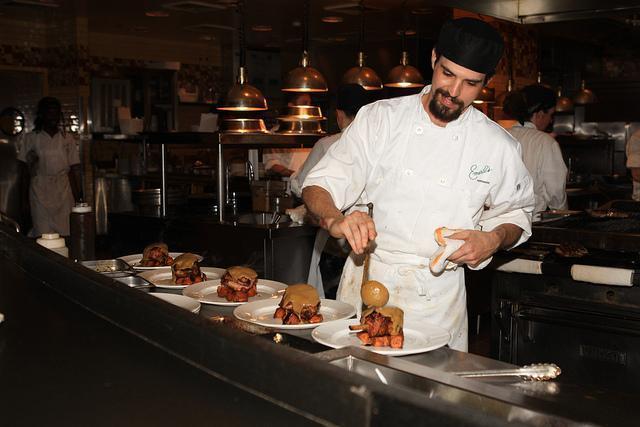How many people are in the picture?
Give a very brief answer. 4. 